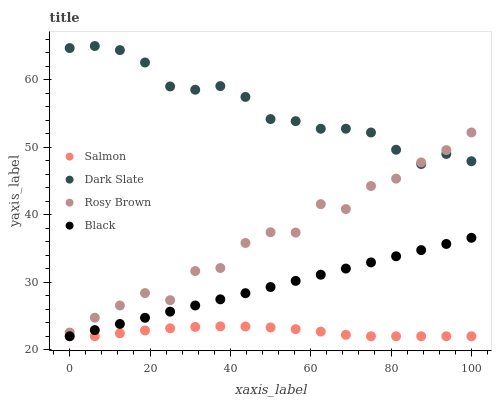Does Salmon have the minimum area under the curve?
Answer yes or no. Yes. Does Dark Slate have the maximum area under the curve?
Answer yes or no. Yes. Does Rosy Brown have the minimum area under the curve?
Answer yes or no. No. Does Rosy Brown have the maximum area under the curve?
Answer yes or no. No. Is Black the smoothest?
Answer yes or no. Yes. Is Rosy Brown the roughest?
Answer yes or no. Yes. Is Salmon the smoothest?
Answer yes or no. No. Is Salmon the roughest?
Answer yes or no. No. Does Salmon have the lowest value?
Answer yes or no. Yes. Does Rosy Brown have the lowest value?
Answer yes or no. No. Does Dark Slate have the highest value?
Answer yes or no. Yes. Does Rosy Brown have the highest value?
Answer yes or no. No. Is Salmon less than Dark Slate?
Answer yes or no. Yes. Is Rosy Brown greater than Salmon?
Answer yes or no. Yes. Does Salmon intersect Black?
Answer yes or no. Yes. Is Salmon less than Black?
Answer yes or no. No. Is Salmon greater than Black?
Answer yes or no. No. Does Salmon intersect Dark Slate?
Answer yes or no. No. 